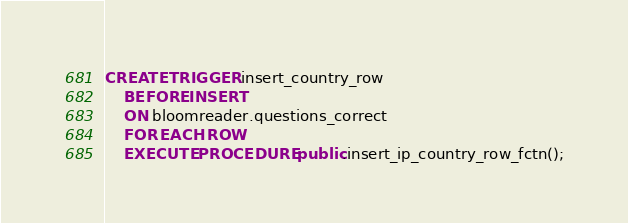<code> <loc_0><loc_0><loc_500><loc_500><_SQL_>
CREATE TRIGGER insert_country_row 
    BEFORE INSERT
    ON bloomreader.questions_correct
    FOR EACH ROW
    EXECUTE PROCEDURE public.insert_ip_country_row_fctn();</code> 